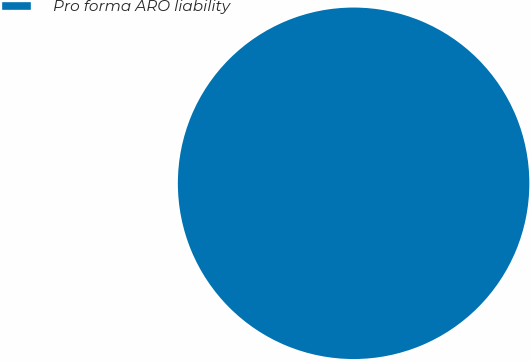Convert chart. <chart><loc_0><loc_0><loc_500><loc_500><pie_chart><fcel>Pro forma ARO liability<nl><fcel>100.0%<nl></chart> 